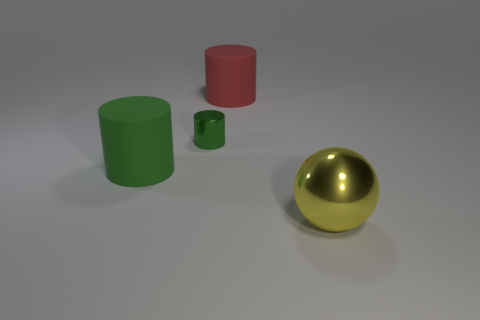Is there any other thing that is the same size as the shiny cylinder?
Offer a terse response. No. What number of other objects are there of the same color as the large metallic object?
Ensure brevity in your answer.  0. Are there any large metallic things on the left side of the tiny green cylinder?
Make the answer very short. No. There is a big matte object that is on the left side of the large cylinder right of the rubber cylinder in front of the tiny green cylinder; what color is it?
Give a very brief answer. Green. How many matte things are both to the left of the big red matte cylinder and right of the large green matte object?
Ensure brevity in your answer.  0. What number of cubes are either tiny blue rubber things or large metal things?
Keep it short and to the point. 0. Are there any big brown matte objects?
Keep it short and to the point. No. What number of other objects are the same material as the small green thing?
Give a very brief answer. 1. There is a green thing that is the same size as the sphere; what is its material?
Your response must be concise. Rubber. Do the matte object that is right of the tiny green object and the small object have the same shape?
Your answer should be compact. Yes. 